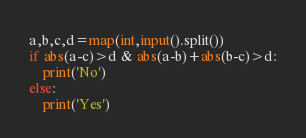Convert code to text. <code><loc_0><loc_0><loc_500><loc_500><_Python_>a,b,c,d=map(int,input().split())
if abs(a-c)>d & abs(a-b)+abs(b-c)>d:
    print('No')
else:
    print('Yes')</code> 